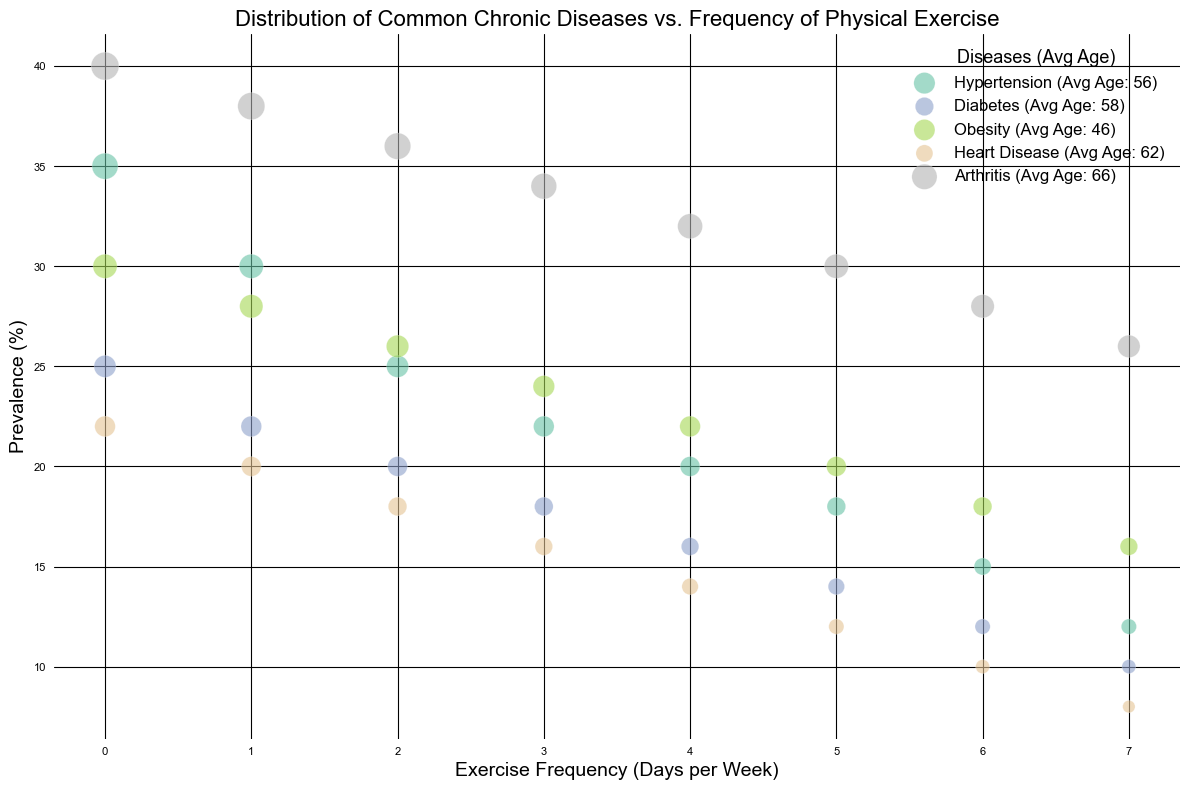What's the most prevalent disease among people who exercise 0 days per week? Look at the bubbles at the Exercise Frequency (Days per Week) = 0. The largest bubble represents the highest prevalence. Arthritis has the largest bubble, indicating a prevalence of 40%.
Answer: Arthritis Which disease shows the greatest reduction in prevalence from 0 days to 7 days of exercise? For each disease, compare the prevalence at 0 days and 7 days. Calculate the reduction for each. The largest reduction is observed in Arthritis, from 40% to 26%, a reduction of 14 percentage points.
Answer: Arthritis What is the average age of people with Heart Disease who exercise 2 days per week? Look at the bubble corresponding to Heart Disease at 2 days of exercise per week. The average age is given as 63 years.
Answer: 63 years How does the prevalence of Diabetes compare on 4 days and 6 days of exercise per week? Find the bubbles corresponding to Diabetes at 4 days and 6 days of exercise. The prevalence is 16% at 4 days and 12% at 6 days. Comparing these, 16% is greater than 12%.
Answer: 16% is greater than 12% Is the trend between exercise frequency and prevalence consistent for all diseases? Observe the pattern of bubbles for each disease. Generally, all diseases show a decreasing trend in prevalence as exercise frequency increases. This indicates a consistent trend across diseases.
Answer: Yes Which disease has the lowest prevalence at any exercise frequency level? Identify the smallest bubble across the chart. The smallest bubble is for Heart Disease at 7 days of exercise per week, with a prevalence of 8%.
Answer: Heart Disease What is the average prevalence of Hypertension across all exercise frequencies? Sum the prevalence percentages for Hypertension across all exercise frequencies: 35 + 30 + 25 + 22 + 20 + 18 + 15 + 12 = 177%. Divide by the number of frequencies (8). Average = 177 / 8 = 22.125%.
Answer: 22.125% Compare the average age of individuals with Arthritis and Hypertension. Which is higher? Calculate average age for each disease. Average age for Arthritis: (70+69+68+67+66+65+64+63)/8 = 66.5 years. Average age for Hypertension: (60+59+58+57+56+55+54+53)/8 = 56.5 years. 66.5 years is higher than 56.5 years.
Answer: Arthritis 